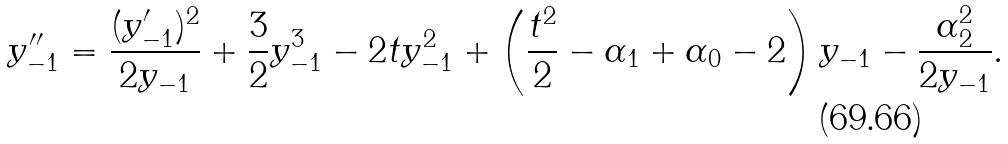<formula> <loc_0><loc_0><loc_500><loc_500>y _ { - 1 } ^ { \prime \prime } = \frac { ( y _ { - 1 } ^ { \prime } ) ^ { 2 } } { 2 y _ { - 1 } } + \frac { 3 } { 2 } y _ { - 1 } ^ { 3 } - 2 t y _ { - 1 } ^ { 2 } + \left ( \frac { t ^ { 2 } } { 2 } - \alpha _ { 1 } + \alpha _ { 0 } - 2 \right ) y _ { - 1 } - \frac { \alpha _ { 2 } ^ { 2 } } { 2 y _ { - 1 } } .</formula> 